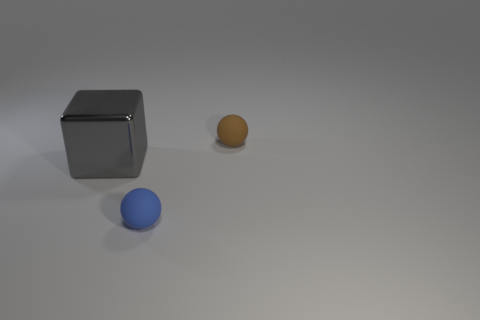Add 2 small brown balls. How many objects exist? 5 Subtract all blocks. How many objects are left? 2 Subtract all brown blocks. Subtract all red cylinders. How many blocks are left? 1 Subtract all blue cubes. How many blue balls are left? 1 Subtract all blue rubber objects. Subtract all big rubber balls. How many objects are left? 2 Add 3 tiny brown matte objects. How many tiny brown matte objects are left? 4 Add 1 blue rubber objects. How many blue rubber objects exist? 2 Subtract 0 green cubes. How many objects are left? 3 